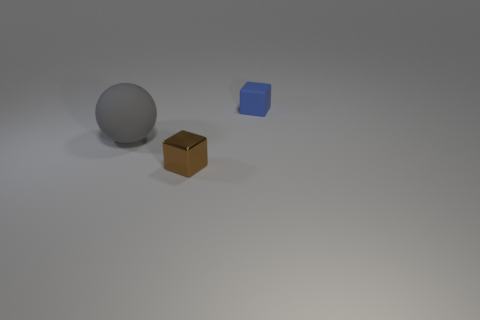Is there a tiny metallic cube that has the same color as the small matte object?
Your response must be concise. No. Are there more brown blocks that are to the right of the blue cube than small red spheres?
Give a very brief answer. No. There is a blue matte object; is its shape the same as the matte thing that is to the left of the shiny block?
Give a very brief answer. No. Are any balls visible?
Your answer should be compact. Yes. What number of large objects are blue metallic things or gray things?
Offer a terse response. 1. Is the number of matte spheres right of the small brown metallic cube greater than the number of small brown cubes on the left side of the large object?
Ensure brevity in your answer.  No. Is the sphere made of the same material as the cube that is in front of the small blue rubber cube?
Offer a very short reply. No. What color is the ball?
Your answer should be compact. Gray. There is a thing to the right of the metal object; what is its shape?
Give a very brief answer. Cube. What number of yellow things are big things or small rubber balls?
Provide a succinct answer. 0. 